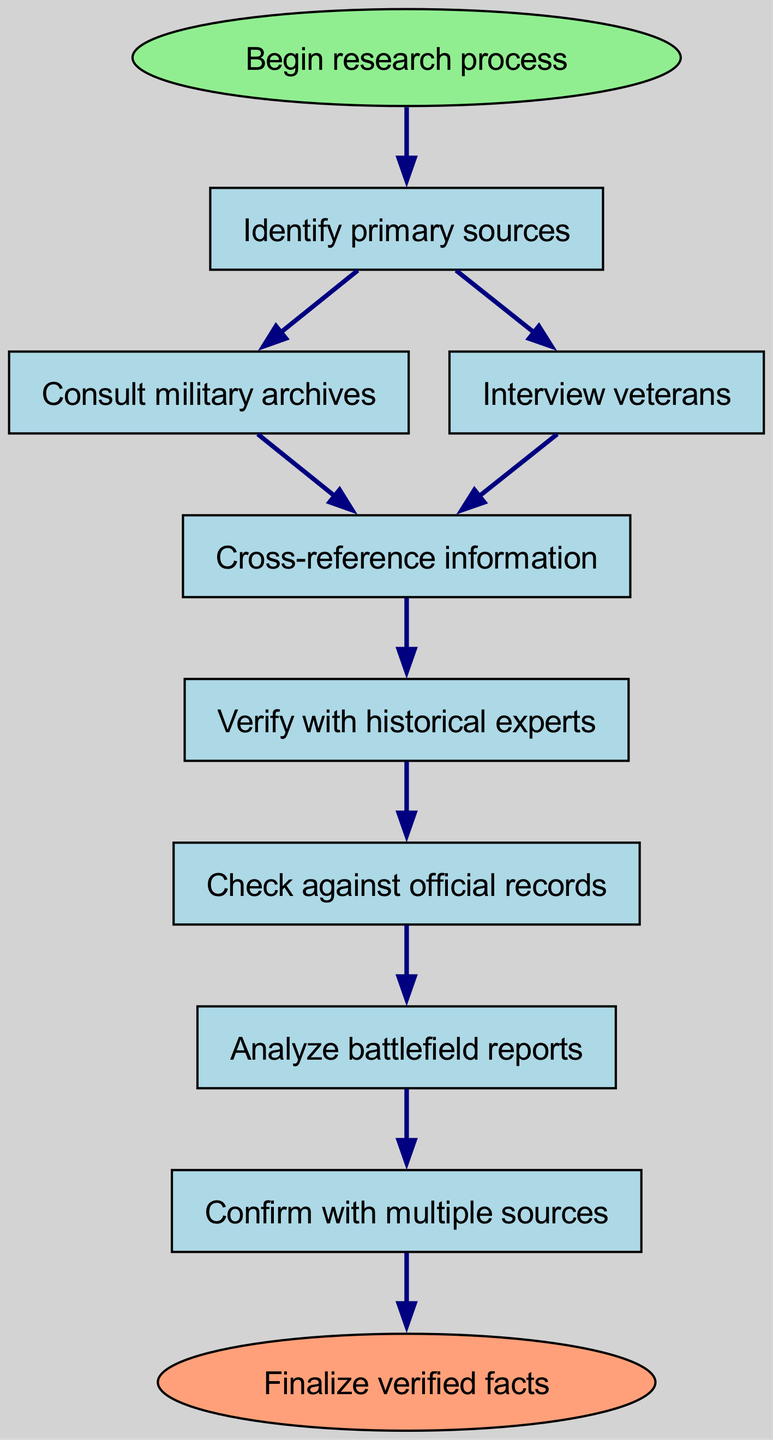What is the first step in the research process? The diagram begins with the node labeled "Begin research process," indicating that this is the first step. Therefore, the answer is found at the start of the flow chart.
Answer: Begin research process How many primary sources need to be identified? The flowchart has a single node labeled "Identify primary sources" connected to the start node, indicating that only one step is shown for identifying primary sources in this part of the process.
Answer: One What follows after consulting military archives? After "Consult military archives," the next node is "Cross-reference information," showing the sequential flow of the process from military archives to cross-referencing.
Answer: Cross-reference information Which step requires consulting historical experts? The step labeled "Verify with historical experts" comes after "Cross-reference information," indicating that experts are consulted to verify the information obtained through earlier steps.
Answer: Verify with historical experts What is the last step of the process? The final node in the flowchart is labeled "Finalize verified facts," which represents the end of the research process. This concludes the overall process described in the diagram.
Answer: Finalize verified facts How many connections does "Analyze battlefield reports" have? The node "Analyze battlefield reports" has a single connection leading to it from "Check against official records," indicating that it is the next step following that node. There are no other connections to this node.
Answer: One What steps directly follow verifying with historical experts? After "Verify with historical experts," the next step is "Check against official records," which leads sequentially. Thus, it requires checking records after verification.
Answer: Check against official records Which two nodes connect to "Cross-reference information"? The two nodes that connect to "Cross-reference information" are "Consult military archives" and "Interview veterans," showing the flow from both of these sources into cross-referencing.
Answer: Consult military archives, Interview veterans If all steps are followed, what is the final outcome of this process? The last node, which represents the outcome of the entire process, is "Finalize verified facts," meaning that the research leads to a conclusion based on all verified information.
Answer: Finalize verified facts 